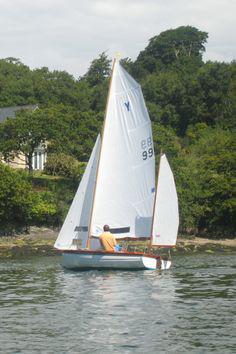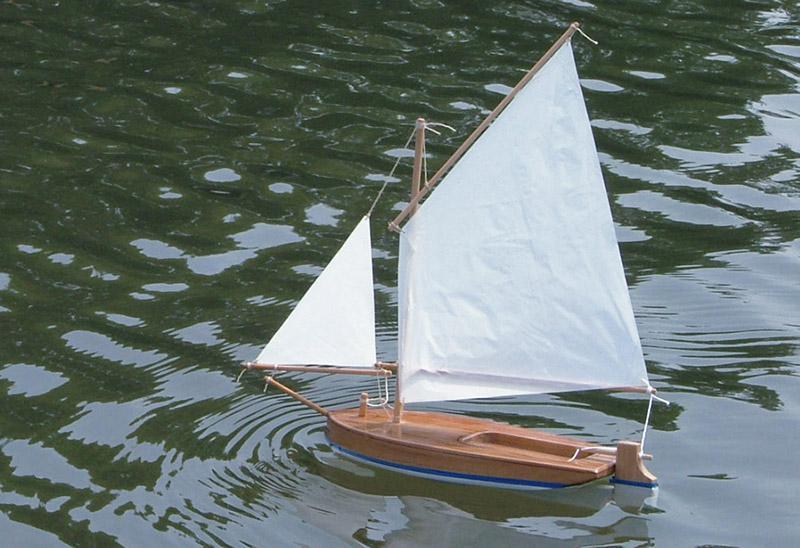The first image is the image on the left, the second image is the image on the right. For the images shown, is this caption "Both of the boats are in the water." true? Answer yes or no. Yes. The first image is the image on the left, the second image is the image on the right. Examine the images to the left and right. Is the description "Each image shows a boat on the water, and at least one of the boats looks like a wooden model instead of a full-size boat." accurate? Answer yes or no. Yes. 